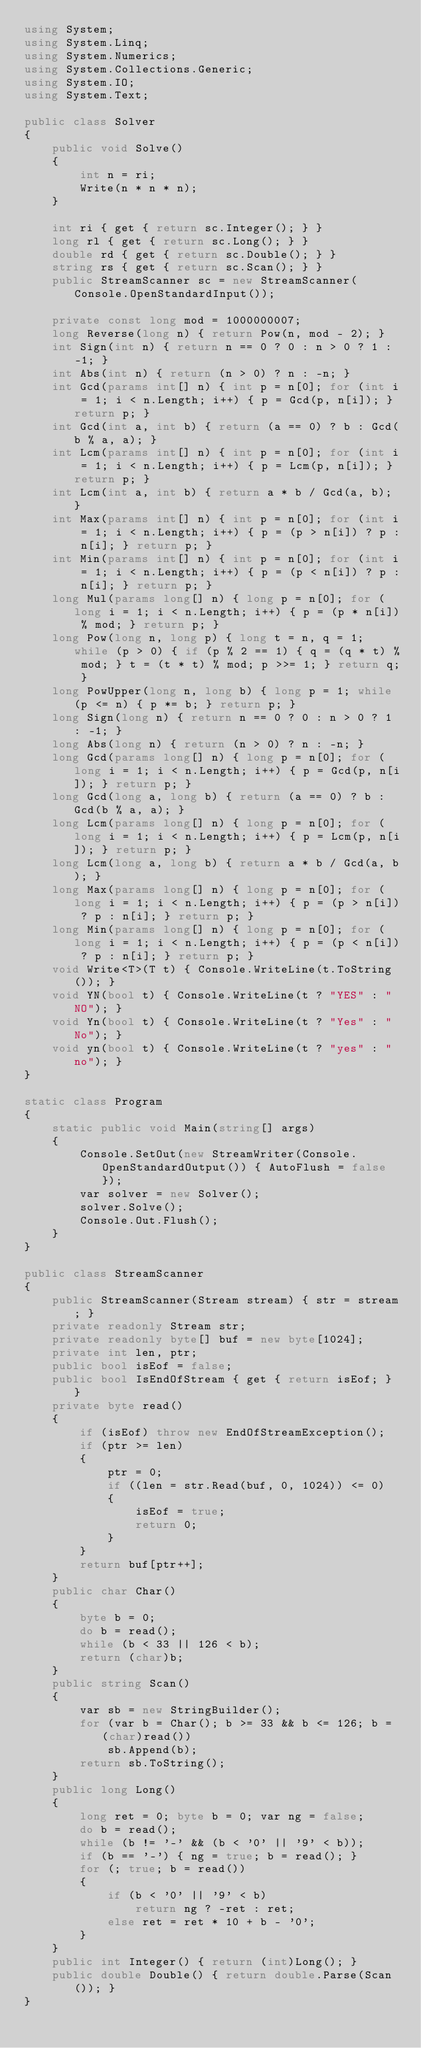<code> <loc_0><loc_0><loc_500><loc_500><_C#_>using System;
using System.Linq;
using System.Numerics;
using System.Collections.Generic;
using System.IO;
using System.Text;

public class Solver
{
    public void Solve()
    {
        int n = ri;
        Write(n * n * n);
    }

    int ri { get { return sc.Integer(); } }
    long rl { get { return sc.Long(); } }
    double rd { get { return sc.Double(); } }
    string rs { get { return sc.Scan(); } }
    public StreamScanner sc = new StreamScanner(Console.OpenStandardInput());
    
    private const long mod = 1000000007;
    long Reverse(long n) { return Pow(n, mod - 2); }
    int Sign(int n) { return n == 0 ? 0 : n > 0 ? 1 : -1; }
    int Abs(int n) { return (n > 0) ? n : -n; }
    int Gcd(params int[] n) { int p = n[0]; for (int i = 1; i < n.Length; i++) { p = Gcd(p, n[i]); } return p; }
    int Gcd(int a, int b) { return (a == 0) ? b : Gcd(b % a, a); }
    int Lcm(params int[] n) { int p = n[0]; for (int i = 1; i < n.Length; i++) { p = Lcm(p, n[i]); } return p; }
    int Lcm(int a, int b) { return a * b / Gcd(a, b); }
    int Max(params int[] n) { int p = n[0]; for (int i = 1; i < n.Length; i++) { p = (p > n[i]) ? p : n[i]; } return p; }
    int Min(params int[] n) { int p = n[0]; for (int i = 1; i < n.Length; i++) { p = (p < n[i]) ? p : n[i]; } return p; }
    long Mul(params long[] n) { long p = n[0]; for (long i = 1; i < n.Length; i++) { p = (p * n[i]) % mod; } return p; }
    long Pow(long n, long p) { long t = n, q = 1; while (p > 0) { if (p % 2 == 1) { q = (q * t) % mod; } t = (t * t) % mod; p >>= 1; } return q; }
    long PowUpper(long n, long b) { long p = 1; while (p <= n) { p *= b; } return p; }
    long Sign(long n) { return n == 0 ? 0 : n > 0 ? 1 : -1; }
    long Abs(long n) { return (n > 0) ? n : -n; }
    long Gcd(params long[] n) { long p = n[0]; for (long i = 1; i < n.Length; i++) { p = Gcd(p, n[i]); } return p; }
    long Gcd(long a, long b) { return (a == 0) ? b : Gcd(b % a, a); }
    long Lcm(params long[] n) { long p = n[0]; for (long i = 1; i < n.Length; i++) { p = Lcm(p, n[i]); } return p; }
    long Lcm(long a, long b) { return a * b / Gcd(a, b); }
    long Max(params long[] n) { long p = n[0]; for (long i = 1; i < n.Length; i++) { p = (p > n[i]) ? p : n[i]; } return p; }
    long Min(params long[] n) { long p = n[0]; for (long i = 1; i < n.Length; i++) { p = (p < n[i]) ? p : n[i]; } return p; }
    void Write<T>(T t) { Console.WriteLine(t.ToString()); }
    void YN(bool t) { Console.WriteLine(t ? "YES" : "NO"); }
    void Yn(bool t) { Console.WriteLine(t ? "Yes" : "No"); }
    void yn(bool t) { Console.WriteLine(t ? "yes" : "no"); }
}

static class Program
{
    static public void Main(string[] args)
    {
        Console.SetOut(new StreamWriter(Console.OpenStandardOutput()) { AutoFlush = false });
        var solver = new Solver();
        solver.Solve();
        Console.Out.Flush();
    }
}

public class StreamScanner
{
    public StreamScanner(Stream stream) { str = stream; }
    private readonly Stream str;
    private readonly byte[] buf = new byte[1024];
    private int len, ptr;
    public bool isEof = false;
    public bool IsEndOfStream { get { return isEof; } }
    private byte read()
    {
        if (isEof) throw new EndOfStreamException();
        if (ptr >= len)
        {
            ptr = 0;
            if ((len = str.Read(buf, 0, 1024)) <= 0)
            {
                isEof = true;
                return 0;
            }
        }
        return buf[ptr++];
    }
    public char Char()
    {
        byte b = 0;
        do b = read();
        while (b < 33 || 126 < b);
        return (char)b;
    }
    public string Scan()
    {
        var sb = new StringBuilder();
        for (var b = Char(); b >= 33 && b <= 126; b = (char)read())
            sb.Append(b);
        return sb.ToString();
    }
    public long Long()
    {
        long ret = 0; byte b = 0; var ng = false;
        do b = read();
        while (b != '-' && (b < '0' || '9' < b));
        if (b == '-') { ng = true; b = read(); }
        for (; true; b = read())
        {
            if (b < '0' || '9' < b)
                return ng ? -ret : ret;
            else ret = ret * 10 + b - '0';
        }
    }
    public int Integer() { return (int)Long(); }
    public double Double() { return double.Parse(Scan()); }
}
</code> 